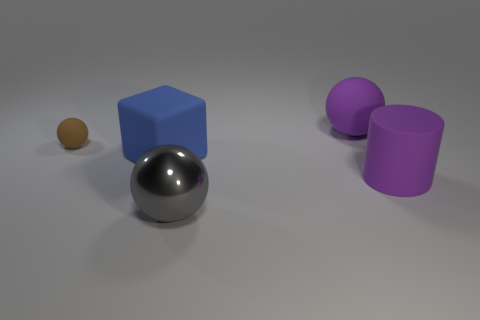Can you guess the size of these objects? Without a clear point of reference, it's challenging to ascertain the exact size, but based on common objects, the sphere and cubes might be similar in size to a baseball and dice, respectively, while the cylinders could be akin to a standard drinking glass in height. 